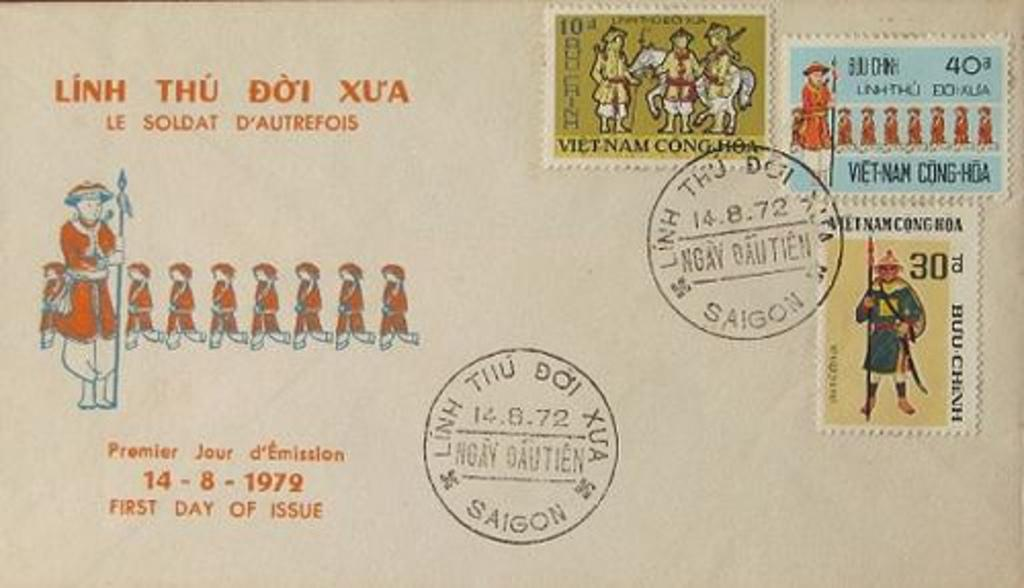<image>
Relay a brief, clear account of the picture shown. a postcard with Vietnamese stamps and the words "Linh Thu Doi Xu'a" 